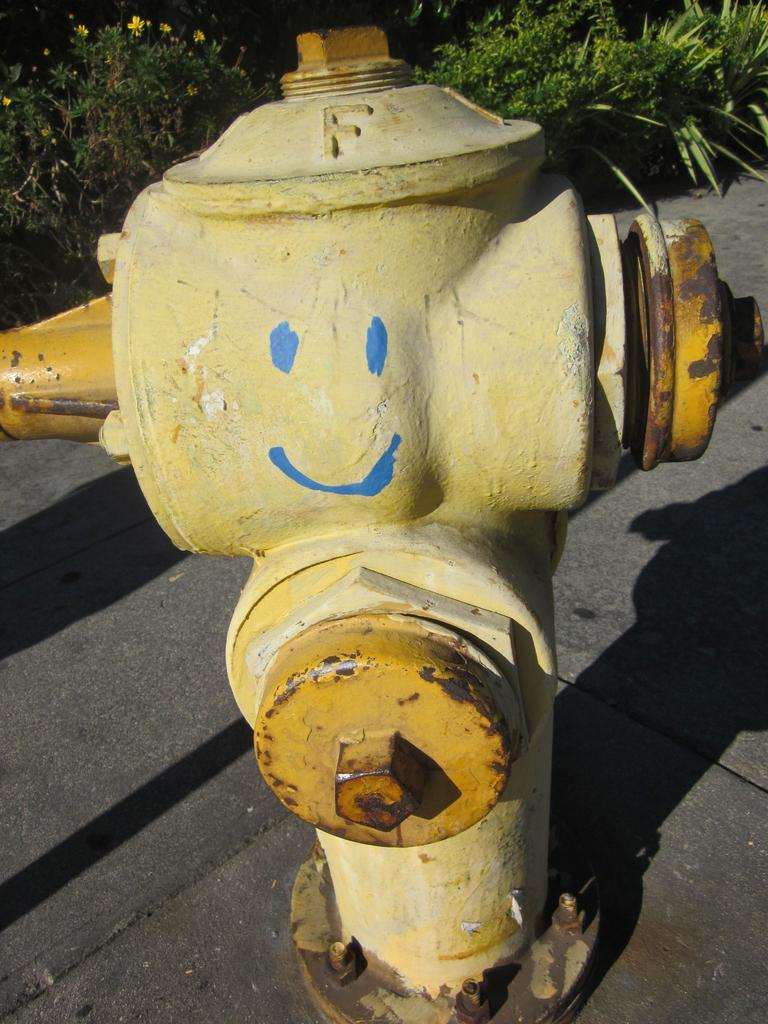Please provide a concise description of this image. In this image we can see a fire hydrant on the road and in the background there are few trees and flowers. 